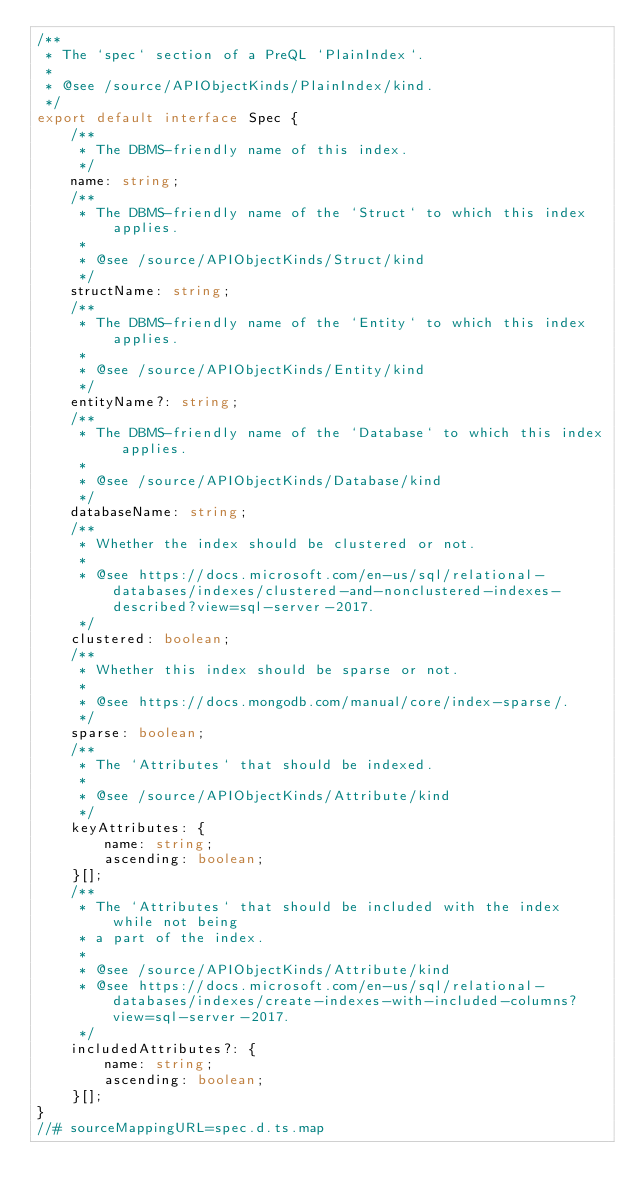<code> <loc_0><loc_0><loc_500><loc_500><_TypeScript_>/**
 * The `spec` section of a PreQL `PlainIndex`.
 *
 * @see /source/APIObjectKinds/PlainIndex/kind.
 */
export default interface Spec {
    /**
     * The DBMS-friendly name of this index.
     */
    name: string;
    /**
     * The DBMS-friendly name of the `Struct` to which this index applies.
     *
     * @see /source/APIObjectKinds/Struct/kind
     */
    structName: string;
    /**
     * The DBMS-friendly name of the `Entity` to which this index applies.
     *
     * @see /source/APIObjectKinds/Entity/kind
     */
    entityName?: string;
    /**
     * The DBMS-friendly name of the `Database` to which this index applies.
     *
     * @see /source/APIObjectKinds/Database/kind
     */
    databaseName: string;
    /**
     * Whether the index should be clustered or not.
     *
     * @see https://docs.microsoft.com/en-us/sql/relational-databases/indexes/clustered-and-nonclustered-indexes-described?view=sql-server-2017.
     */
    clustered: boolean;
    /**
     * Whether this index should be sparse or not.
     *
     * @see https://docs.mongodb.com/manual/core/index-sparse/.
     */
    sparse: boolean;
    /**
     * The `Attributes` that should be indexed.
     *
     * @see /source/APIObjectKinds/Attribute/kind
     */
    keyAttributes: {
        name: string;
        ascending: boolean;
    }[];
    /**
     * The `Attributes` that should be included with the index while not being
     * a part of the index.
     *
     * @see /source/APIObjectKinds/Attribute/kind
     * @see https://docs.microsoft.com/en-us/sql/relational-databases/indexes/create-indexes-with-included-columns?view=sql-server-2017.
     */
    includedAttributes?: {
        name: string;
        ascending: boolean;
    }[];
}
//# sourceMappingURL=spec.d.ts.map</code> 